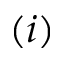<formula> <loc_0><loc_0><loc_500><loc_500>( i )</formula> 